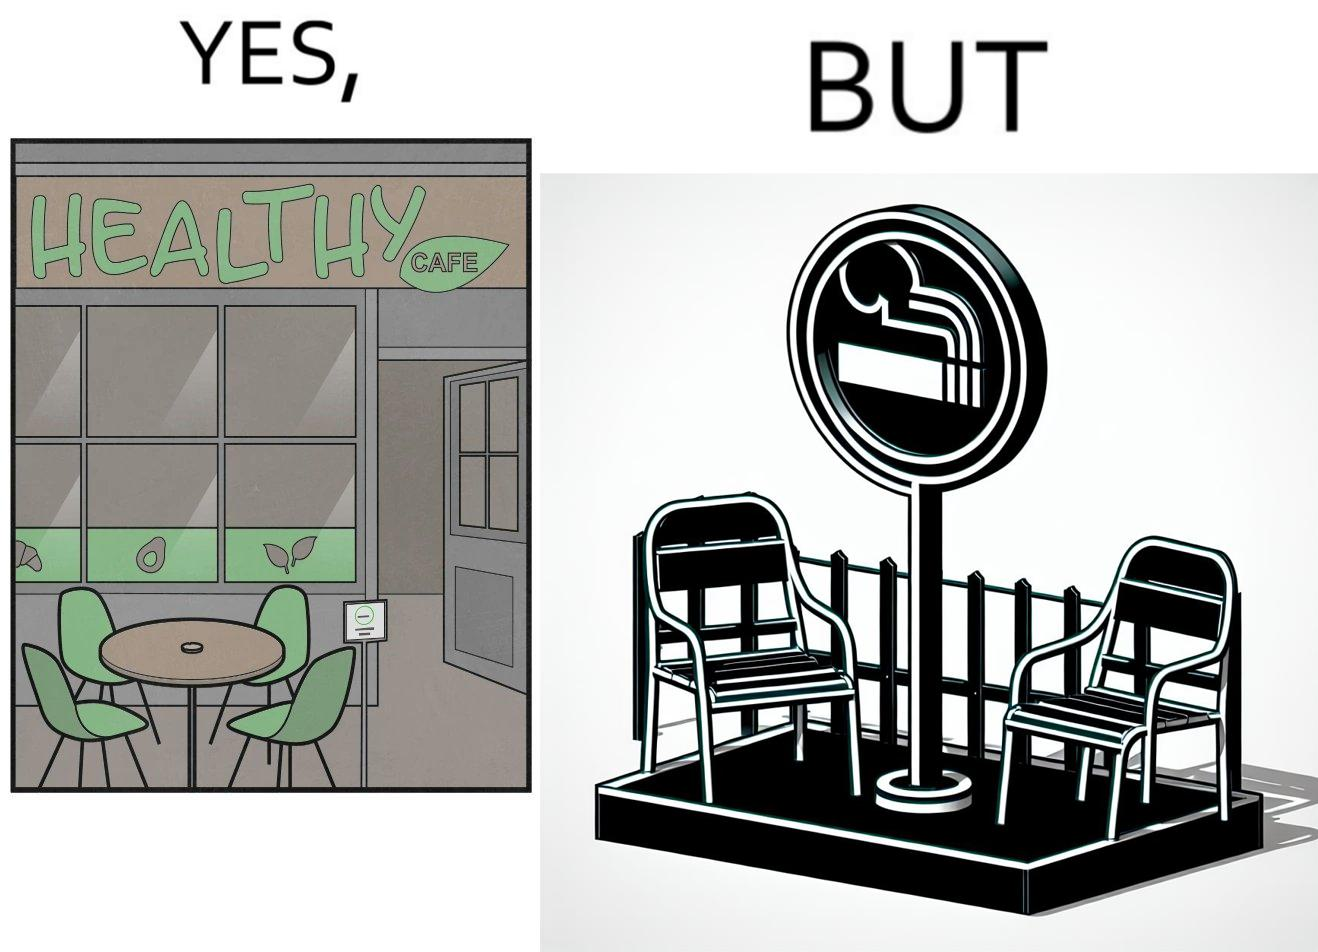What do you see in each half of this image? In the left part of the image: An eatery with the name "Healthy Cafe". It has a green aesthetic with paintings of leaves, avocados, etc on their windows. They have an outdoor seating area with 4 green patio chairs around a circular table. There is a small sign on a stand near the table with a green circular symbol and some text that is too small to read. In the right part of the image: Green patio chairs. A sign on a stand that has a green circular symbol encircling a cigarette symbol, and some text that says "SMOKING AREA". 